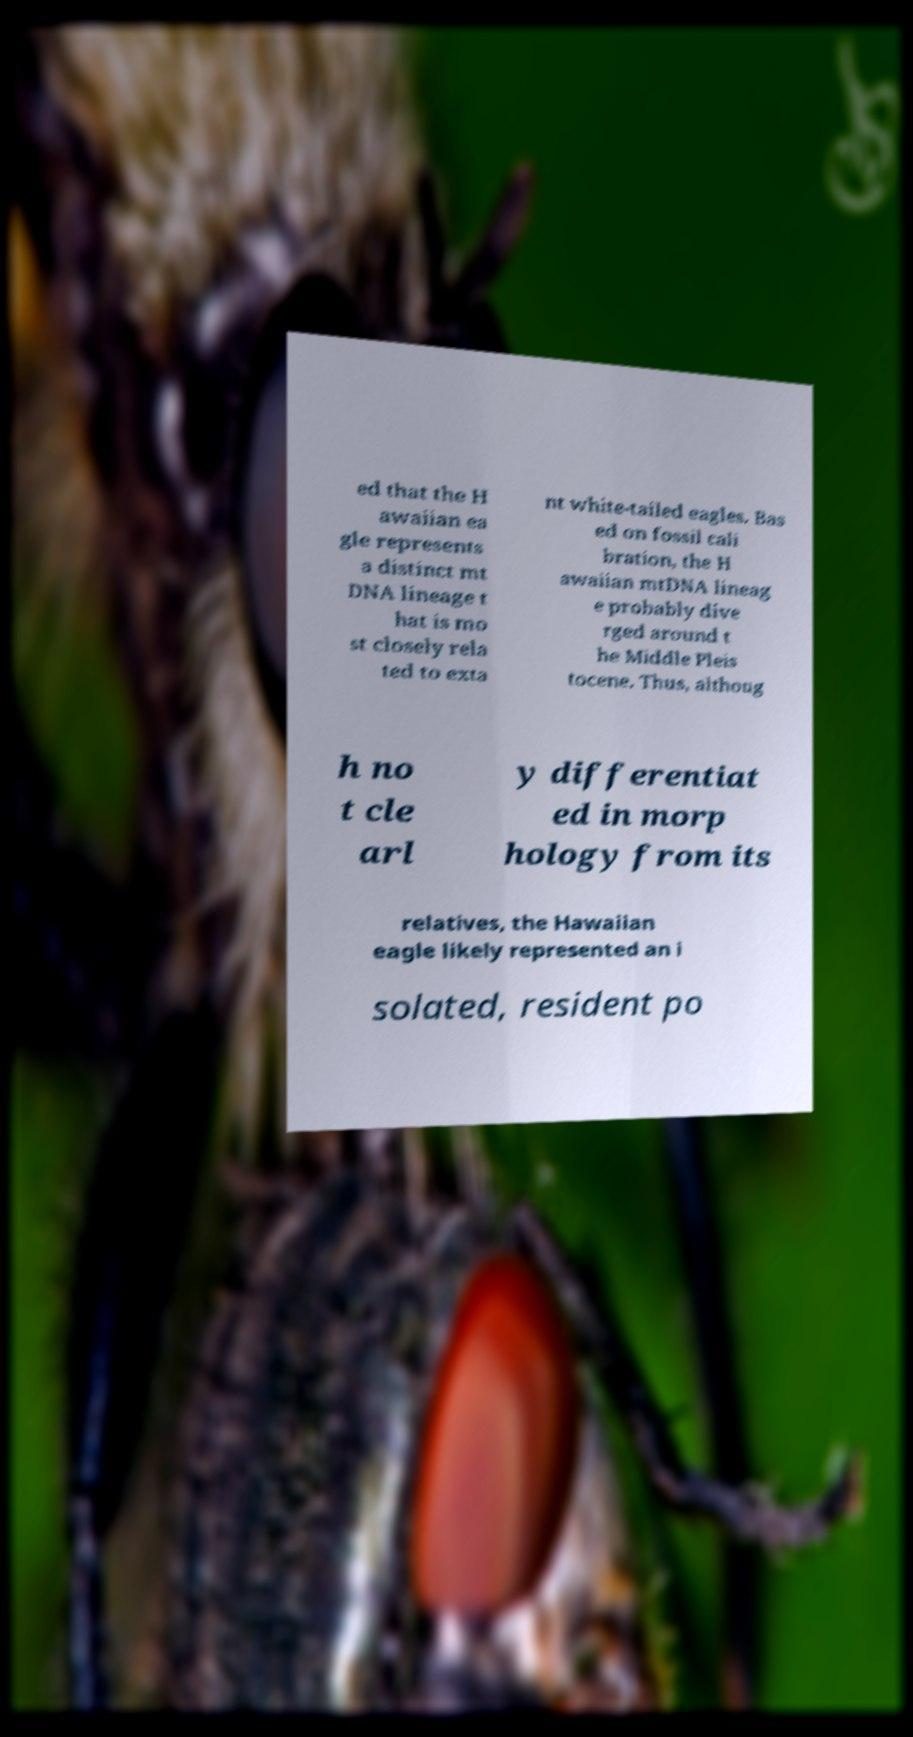Can you read and provide the text displayed in the image?This photo seems to have some interesting text. Can you extract and type it out for me? ed that the H awaiian ea gle represents a distinct mt DNA lineage t hat is mo st closely rela ted to exta nt white-tailed eagles. Bas ed on fossil cali bration, the H awaiian mtDNA lineag e probably dive rged around t he Middle Pleis tocene. Thus, althoug h no t cle arl y differentiat ed in morp hology from its relatives, the Hawaiian eagle likely represented an i solated, resident po 